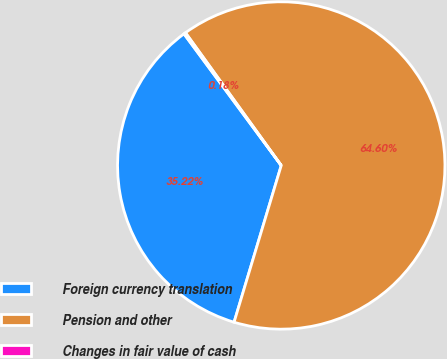Convert chart to OTSL. <chart><loc_0><loc_0><loc_500><loc_500><pie_chart><fcel>Foreign currency translation<fcel>Pension and other<fcel>Changes in fair value of cash<nl><fcel>35.22%<fcel>64.6%<fcel>0.18%<nl></chart> 